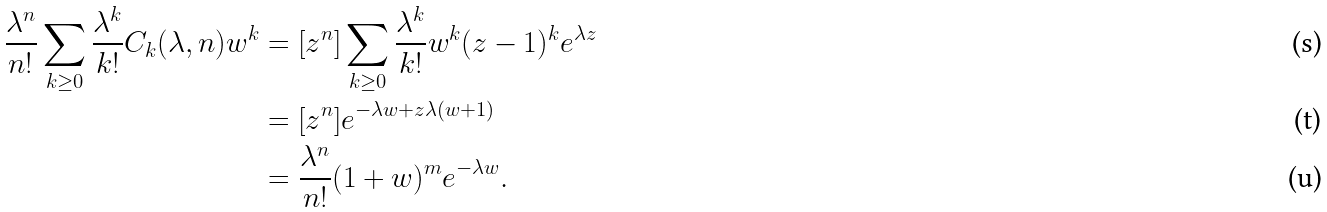<formula> <loc_0><loc_0><loc_500><loc_500>\frac { \lambda ^ { n } } { n ! } \sum _ { k \geq 0 } \frac { \lambda ^ { k } } { k ! } C _ { k } ( \lambda , n ) w ^ { k } & = [ z ^ { n } ] \sum _ { k \geq 0 } \frac { \lambda ^ { k } } { k ! } w ^ { k } ( z - 1 ) ^ { k } e ^ { \lambda z } \\ & = [ z ^ { n } ] e ^ { - \lambda w + z \lambda ( w + 1 ) } \\ & = \frac { \lambda ^ { n } } { n ! } ( 1 + w ) ^ { m } e ^ { - \lambda w } .</formula> 